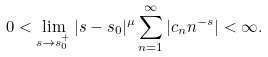<formula> <loc_0><loc_0><loc_500><loc_500>0 < \lim _ { s \rightarrow s _ { 0 } ^ { + } } | s - s _ { 0 } | ^ { \mu } \sum _ { n = 1 } ^ { \infty } | c _ { n } n ^ { - s } | < \infty .</formula> 